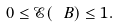<formula> <loc_0><loc_0><loc_500><loc_500>0 \leq { \mathcal { E } } ( \ B ) \leq 1 .</formula> 